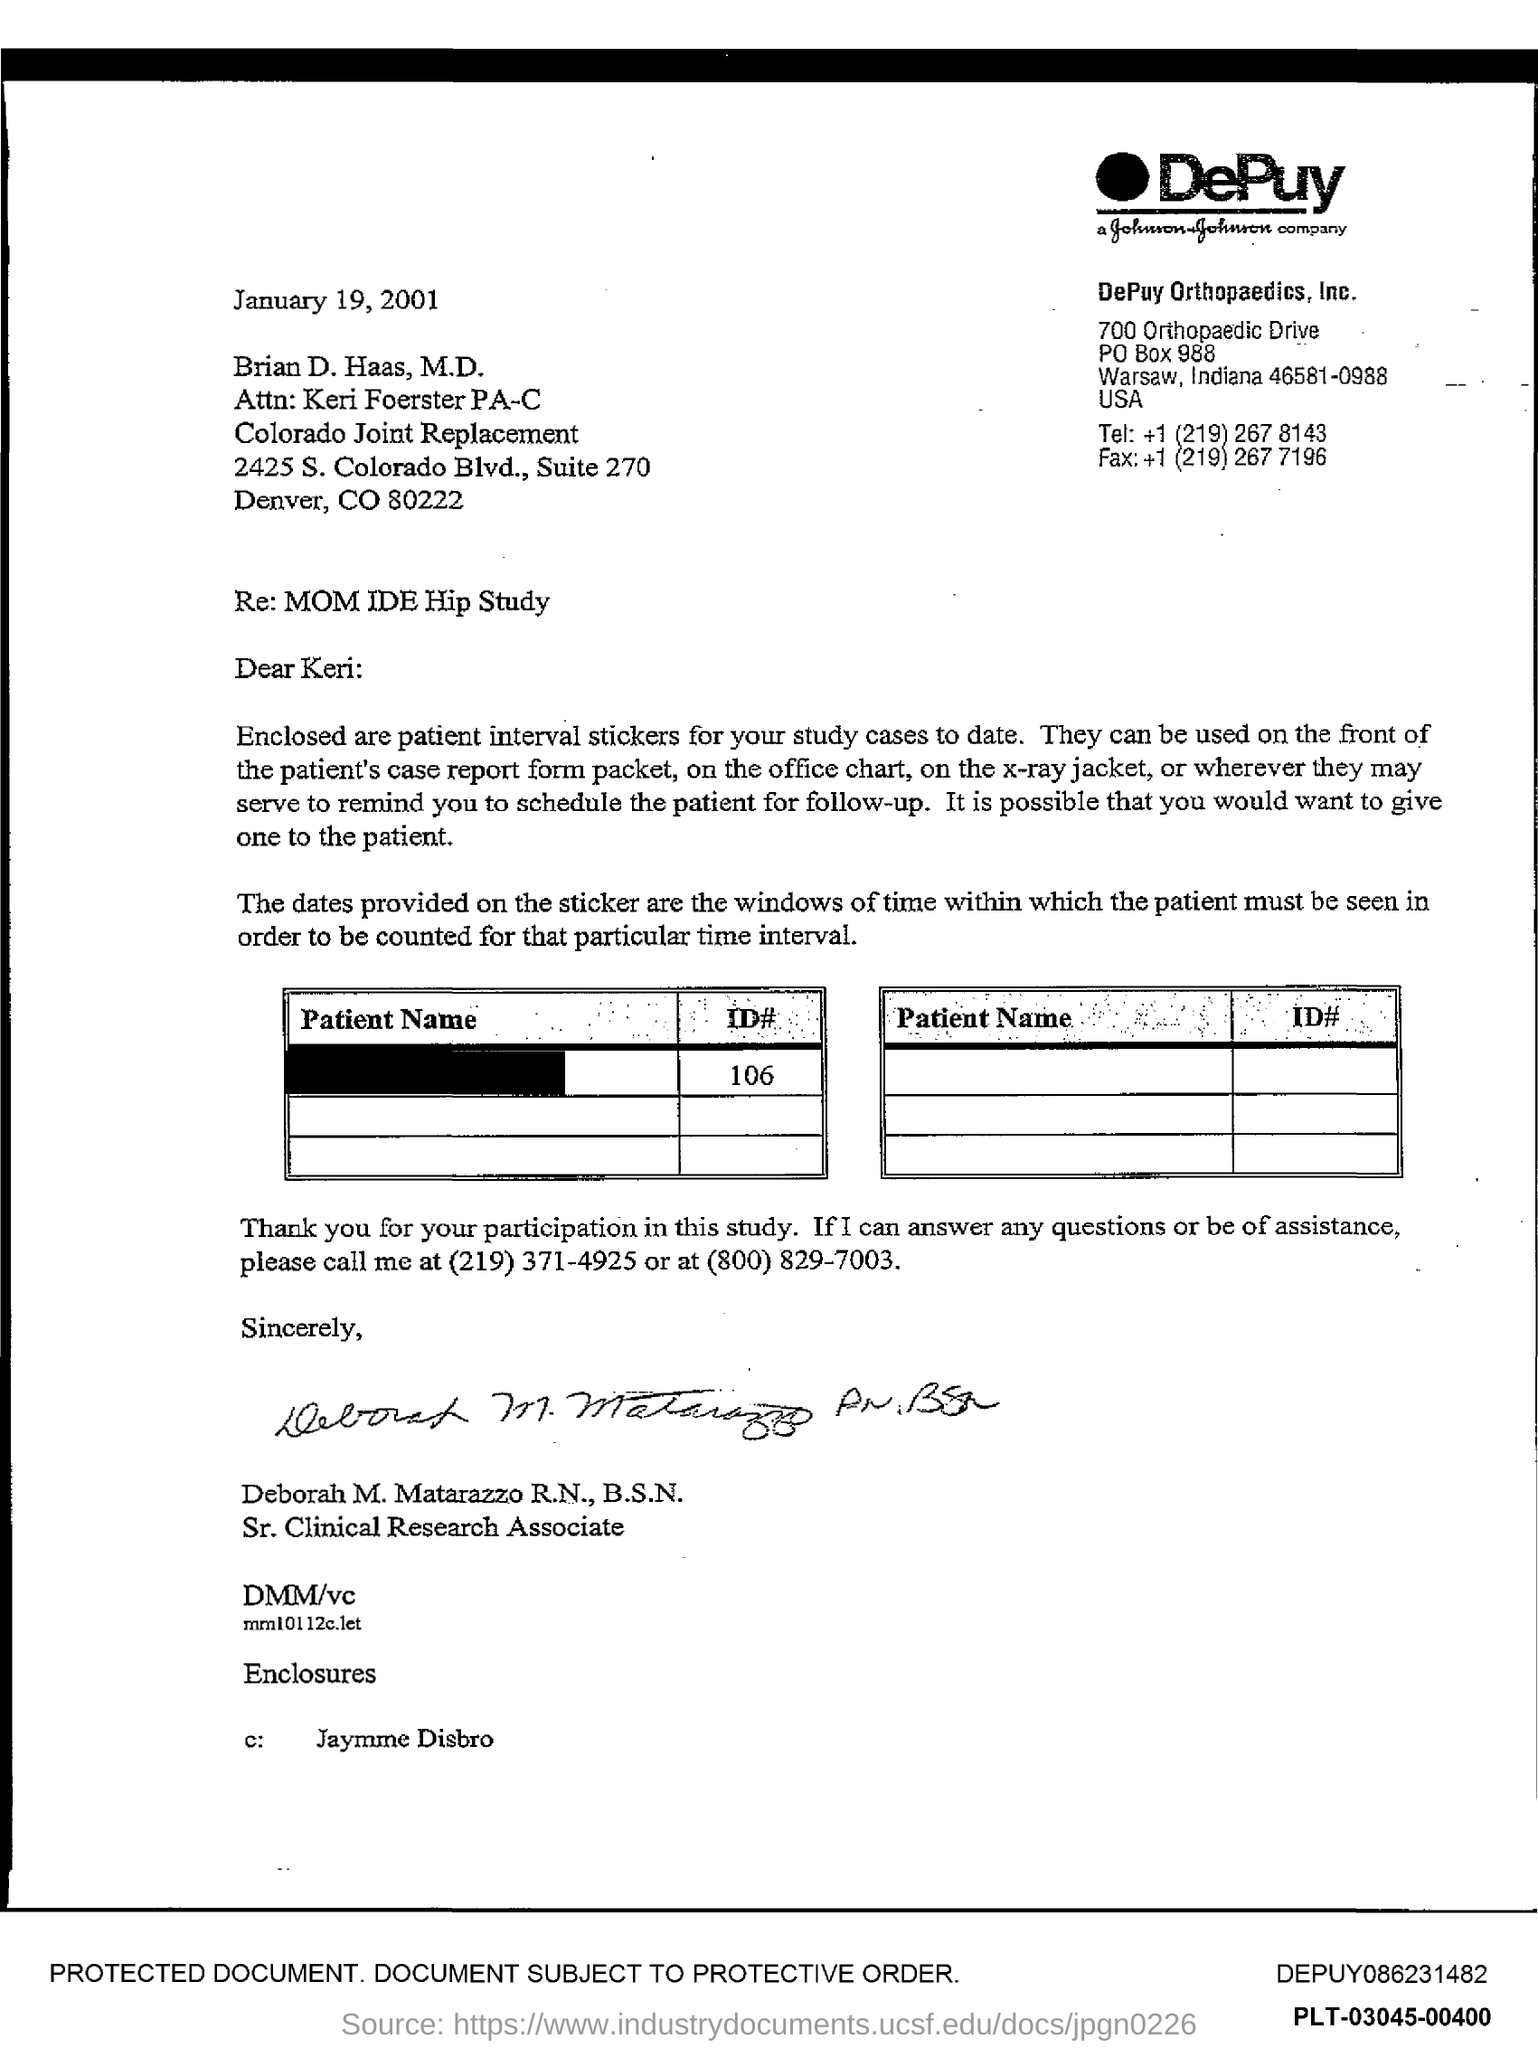Identify some key points in this picture. The document mentions a PO Box number as 988.. 